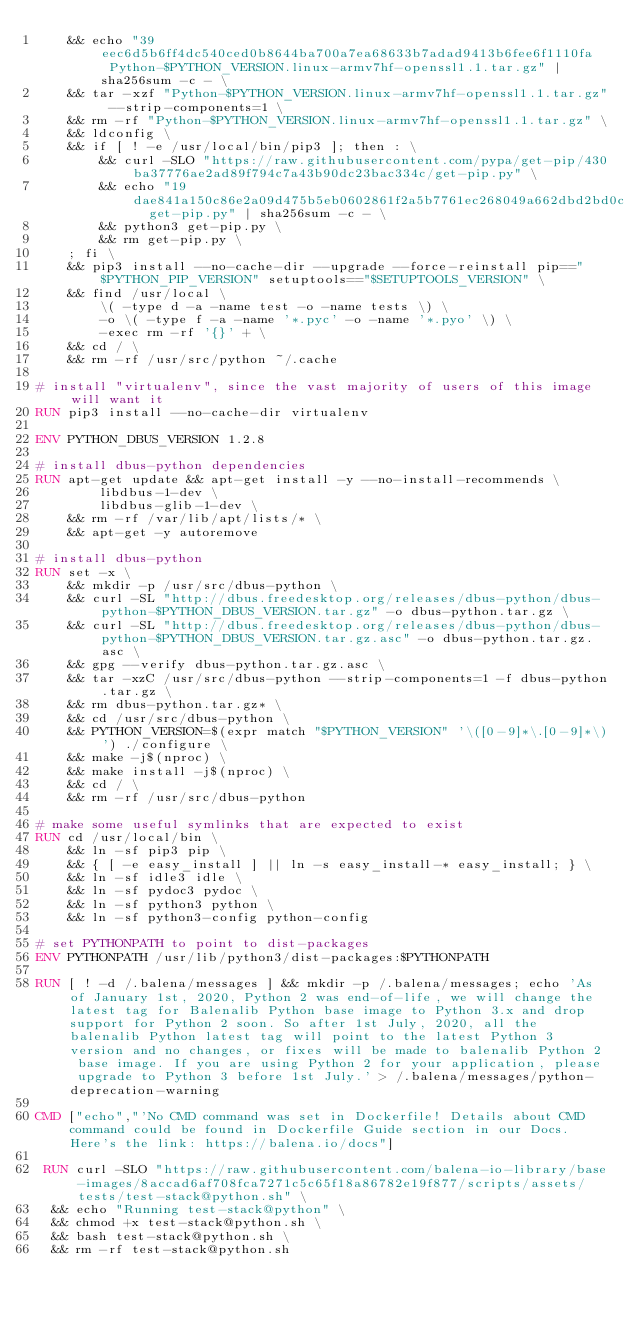Convert code to text. <code><loc_0><loc_0><loc_500><loc_500><_Dockerfile_>	&& echo "39eec6d5b6ff4dc540ced0b8644ba700a7ea68633b7adad9413b6fee6f1110fa  Python-$PYTHON_VERSION.linux-armv7hf-openssl1.1.tar.gz" | sha256sum -c - \
	&& tar -xzf "Python-$PYTHON_VERSION.linux-armv7hf-openssl1.1.tar.gz" --strip-components=1 \
	&& rm -rf "Python-$PYTHON_VERSION.linux-armv7hf-openssl1.1.tar.gz" \
	&& ldconfig \
	&& if [ ! -e /usr/local/bin/pip3 ]; then : \
		&& curl -SLO "https://raw.githubusercontent.com/pypa/get-pip/430ba37776ae2ad89f794c7a43b90dc23bac334c/get-pip.py" \
		&& echo "19dae841a150c86e2a09d475b5eb0602861f2a5b7761ec268049a662dbd2bd0c  get-pip.py" | sha256sum -c - \
		&& python3 get-pip.py \
		&& rm get-pip.py \
	; fi \
	&& pip3 install --no-cache-dir --upgrade --force-reinstall pip=="$PYTHON_PIP_VERSION" setuptools=="$SETUPTOOLS_VERSION" \
	&& find /usr/local \
		\( -type d -a -name test -o -name tests \) \
		-o \( -type f -a -name '*.pyc' -o -name '*.pyo' \) \
		-exec rm -rf '{}' + \
	&& cd / \
	&& rm -rf /usr/src/python ~/.cache

# install "virtualenv", since the vast majority of users of this image will want it
RUN pip3 install --no-cache-dir virtualenv

ENV PYTHON_DBUS_VERSION 1.2.8

# install dbus-python dependencies 
RUN apt-get update && apt-get install -y --no-install-recommends \
		libdbus-1-dev \
		libdbus-glib-1-dev \
	&& rm -rf /var/lib/apt/lists/* \
	&& apt-get -y autoremove

# install dbus-python
RUN set -x \
	&& mkdir -p /usr/src/dbus-python \
	&& curl -SL "http://dbus.freedesktop.org/releases/dbus-python/dbus-python-$PYTHON_DBUS_VERSION.tar.gz" -o dbus-python.tar.gz \
	&& curl -SL "http://dbus.freedesktop.org/releases/dbus-python/dbus-python-$PYTHON_DBUS_VERSION.tar.gz.asc" -o dbus-python.tar.gz.asc \
	&& gpg --verify dbus-python.tar.gz.asc \
	&& tar -xzC /usr/src/dbus-python --strip-components=1 -f dbus-python.tar.gz \
	&& rm dbus-python.tar.gz* \
	&& cd /usr/src/dbus-python \
	&& PYTHON_VERSION=$(expr match "$PYTHON_VERSION" '\([0-9]*\.[0-9]*\)') ./configure \
	&& make -j$(nproc) \
	&& make install -j$(nproc) \
	&& cd / \
	&& rm -rf /usr/src/dbus-python

# make some useful symlinks that are expected to exist
RUN cd /usr/local/bin \
	&& ln -sf pip3 pip \
	&& { [ -e easy_install ] || ln -s easy_install-* easy_install; } \
	&& ln -sf idle3 idle \
	&& ln -sf pydoc3 pydoc \
	&& ln -sf python3 python \
	&& ln -sf python3-config python-config

# set PYTHONPATH to point to dist-packages
ENV PYTHONPATH /usr/lib/python3/dist-packages:$PYTHONPATH

RUN [ ! -d /.balena/messages ] && mkdir -p /.balena/messages; echo 'As of January 1st, 2020, Python 2 was end-of-life, we will change the latest tag for Balenalib Python base image to Python 3.x and drop support for Python 2 soon. So after 1st July, 2020, all the balenalib Python latest tag will point to the latest Python 3 version and no changes, or fixes will be made to balenalib Python 2 base image. If you are using Python 2 for your application, please upgrade to Python 3 before 1st July.' > /.balena/messages/python-deprecation-warning

CMD ["echo","'No CMD command was set in Dockerfile! Details about CMD command could be found in Dockerfile Guide section in our Docs. Here's the link: https://balena.io/docs"]

 RUN curl -SLO "https://raw.githubusercontent.com/balena-io-library/base-images/8accad6af708fca7271c5c65f18a86782e19f877/scripts/assets/tests/test-stack@python.sh" \
  && echo "Running test-stack@python" \
  && chmod +x test-stack@python.sh \
  && bash test-stack@python.sh \
  && rm -rf test-stack@python.sh 
</code> 